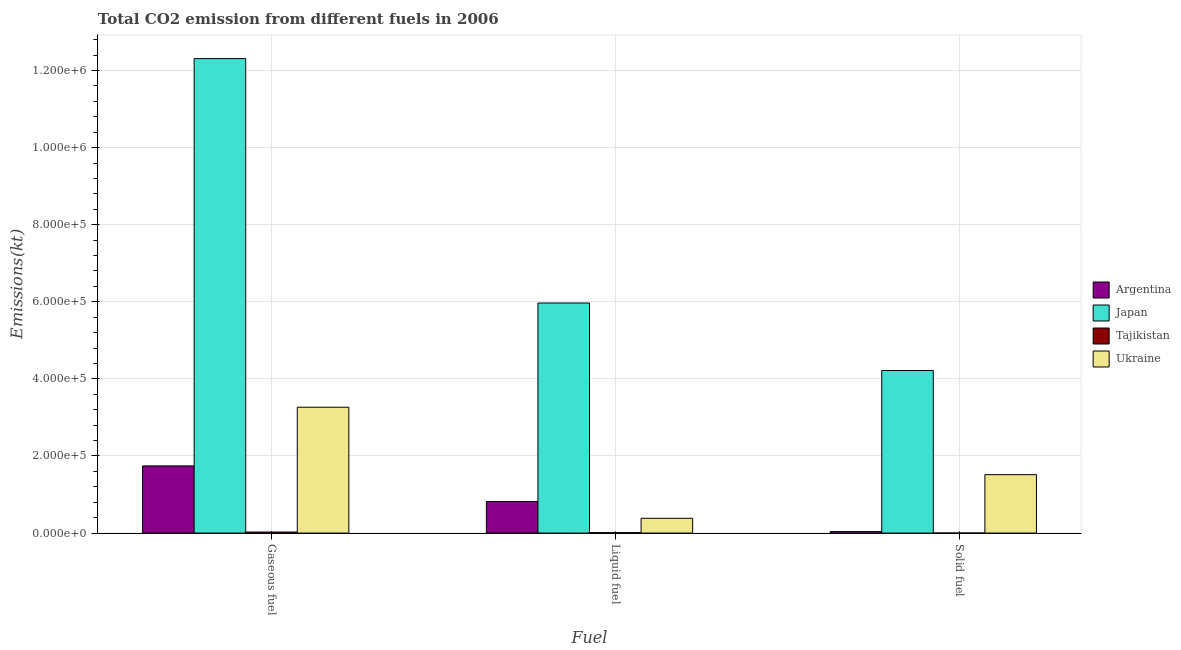How many different coloured bars are there?
Keep it short and to the point. 4. Are the number of bars per tick equal to the number of legend labels?
Ensure brevity in your answer.  Yes. Are the number of bars on each tick of the X-axis equal?
Your answer should be very brief. Yes. How many bars are there on the 1st tick from the left?
Your answer should be compact. 4. What is the label of the 3rd group of bars from the left?
Your answer should be compact. Solid fuel. What is the amount of co2 emissions from liquid fuel in Ukraine?
Your response must be concise. 3.84e+04. Across all countries, what is the maximum amount of co2 emissions from gaseous fuel?
Ensure brevity in your answer.  1.23e+06. Across all countries, what is the minimum amount of co2 emissions from solid fuel?
Your answer should be very brief. 176.02. In which country was the amount of co2 emissions from solid fuel maximum?
Give a very brief answer. Japan. In which country was the amount of co2 emissions from gaseous fuel minimum?
Ensure brevity in your answer.  Tajikistan. What is the total amount of co2 emissions from liquid fuel in the graph?
Provide a short and direct response. 7.18e+05. What is the difference between the amount of co2 emissions from liquid fuel in Japan and that in Ukraine?
Make the answer very short. 5.58e+05. What is the difference between the amount of co2 emissions from liquid fuel in Ukraine and the amount of co2 emissions from gaseous fuel in Argentina?
Your response must be concise. -1.36e+05. What is the average amount of co2 emissions from solid fuel per country?
Provide a succinct answer. 1.44e+05. What is the difference between the amount of co2 emissions from liquid fuel and amount of co2 emissions from solid fuel in Tajikistan?
Make the answer very short. 935.09. What is the ratio of the amount of co2 emissions from liquid fuel in Ukraine to that in Argentina?
Provide a succinct answer. 0.47. What is the difference between the highest and the second highest amount of co2 emissions from gaseous fuel?
Keep it short and to the point. 9.04e+05. What is the difference between the highest and the lowest amount of co2 emissions from solid fuel?
Make the answer very short. 4.22e+05. Is the sum of the amount of co2 emissions from gaseous fuel in Japan and Ukraine greater than the maximum amount of co2 emissions from liquid fuel across all countries?
Your answer should be compact. Yes. What does the 3rd bar from the left in Liquid fuel represents?
Ensure brevity in your answer.  Tajikistan. What does the 1st bar from the right in Gaseous fuel represents?
Your answer should be compact. Ukraine. Is it the case that in every country, the sum of the amount of co2 emissions from gaseous fuel and amount of co2 emissions from liquid fuel is greater than the amount of co2 emissions from solid fuel?
Your answer should be compact. Yes. Are all the bars in the graph horizontal?
Make the answer very short. No. How many countries are there in the graph?
Keep it short and to the point. 4. What is the title of the graph?
Offer a terse response. Total CO2 emission from different fuels in 2006. Does "Guinea" appear as one of the legend labels in the graph?
Make the answer very short. No. What is the label or title of the X-axis?
Provide a short and direct response. Fuel. What is the label or title of the Y-axis?
Ensure brevity in your answer.  Emissions(kt). What is the Emissions(kt) in Argentina in Gaseous fuel?
Offer a terse response. 1.74e+05. What is the Emissions(kt) in Japan in Gaseous fuel?
Keep it short and to the point. 1.23e+06. What is the Emissions(kt) in Tajikistan in Gaseous fuel?
Your response must be concise. 2658.57. What is the Emissions(kt) in Ukraine in Gaseous fuel?
Offer a very short reply. 3.26e+05. What is the Emissions(kt) in Argentina in Liquid fuel?
Offer a terse response. 8.20e+04. What is the Emissions(kt) in Japan in Liquid fuel?
Your answer should be compact. 5.97e+05. What is the Emissions(kt) of Tajikistan in Liquid fuel?
Keep it short and to the point. 1111.1. What is the Emissions(kt) of Ukraine in Liquid fuel?
Your answer should be compact. 3.84e+04. What is the Emissions(kt) of Argentina in Solid fuel?
Your answer should be compact. 3868.68. What is the Emissions(kt) in Japan in Solid fuel?
Offer a terse response. 4.22e+05. What is the Emissions(kt) of Tajikistan in Solid fuel?
Give a very brief answer. 176.02. What is the Emissions(kt) in Ukraine in Solid fuel?
Ensure brevity in your answer.  1.52e+05. Across all Fuel, what is the maximum Emissions(kt) of Argentina?
Give a very brief answer. 1.74e+05. Across all Fuel, what is the maximum Emissions(kt) of Japan?
Keep it short and to the point. 1.23e+06. Across all Fuel, what is the maximum Emissions(kt) in Tajikistan?
Give a very brief answer. 2658.57. Across all Fuel, what is the maximum Emissions(kt) of Ukraine?
Your answer should be very brief. 3.26e+05. Across all Fuel, what is the minimum Emissions(kt) in Argentina?
Your response must be concise. 3868.68. Across all Fuel, what is the minimum Emissions(kt) in Japan?
Offer a terse response. 4.22e+05. Across all Fuel, what is the minimum Emissions(kt) in Tajikistan?
Give a very brief answer. 176.02. Across all Fuel, what is the minimum Emissions(kt) in Ukraine?
Your answer should be compact. 3.84e+04. What is the total Emissions(kt) of Argentina in the graph?
Ensure brevity in your answer.  2.60e+05. What is the total Emissions(kt) in Japan in the graph?
Provide a succinct answer. 2.25e+06. What is the total Emissions(kt) of Tajikistan in the graph?
Provide a succinct answer. 3945.69. What is the total Emissions(kt) in Ukraine in the graph?
Keep it short and to the point. 5.16e+05. What is the difference between the Emissions(kt) of Argentina in Gaseous fuel and that in Liquid fuel?
Your response must be concise. 9.23e+04. What is the difference between the Emissions(kt) of Japan in Gaseous fuel and that in Liquid fuel?
Make the answer very short. 6.34e+05. What is the difference between the Emissions(kt) of Tajikistan in Gaseous fuel and that in Liquid fuel?
Your response must be concise. 1547.47. What is the difference between the Emissions(kt) in Ukraine in Gaseous fuel and that in Liquid fuel?
Offer a terse response. 2.88e+05. What is the difference between the Emissions(kt) in Argentina in Gaseous fuel and that in Solid fuel?
Make the answer very short. 1.70e+05. What is the difference between the Emissions(kt) of Japan in Gaseous fuel and that in Solid fuel?
Your answer should be very brief. 8.09e+05. What is the difference between the Emissions(kt) in Tajikistan in Gaseous fuel and that in Solid fuel?
Give a very brief answer. 2482.56. What is the difference between the Emissions(kt) in Ukraine in Gaseous fuel and that in Solid fuel?
Make the answer very short. 1.75e+05. What is the difference between the Emissions(kt) in Argentina in Liquid fuel and that in Solid fuel?
Offer a terse response. 7.81e+04. What is the difference between the Emissions(kt) in Japan in Liquid fuel and that in Solid fuel?
Your response must be concise. 1.75e+05. What is the difference between the Emissions(kt) of Tajikistan in Liquid fuel and that in Solid fuel?
Keep it short and to the point. 935.09. What is the difference between the Emissions(kt) in Ukraine in Liquid fuel and that in Solid fuel?
Ensure brevity in your answer.  -1.13e+05. What is the difference between the Emissions(kt) of Argentina in Gaseous fuel and the Emissions(kt) of Japan in Liquid fuel?
Make the answer very short. -4.23e+05. What is the difference between the Emissions(kt) in Argentina in Gaseous fuel and the Emissions(kt) in Tajikistan in Liquid fuel?
Provide a short and direct response. 1.73e+05. What is the difference between the Emissions(kt) of Argentina in Gaseous fuel and the Emissions(kt) of Ukraine in Liquid fuel?
Ensure brevity in your answer.  1.36e+05. What is the difference between the Emissions(kt) in Japan in Gaseous fuel and the Emissions(kt) in Tajikistan in Liquid fuel?
Provide a succinct answer. 1.23e+06. What is the difference between the Emissions(kt) of Japan in Gaseous fuel and the Emissions(kt) of Ukraine in Liquid fuel?
Ensure brevity in your answer.  1.19e+06. What is the difference between the Emissions(kt) of Tajikistan in Gaseous fuel and the Emissions(kt) of Ukraine in Liquid fuel?
Your response must be concise. -3.57e+04. What is the difference between the Emissions(kt) of Argentina in Gaseous fuel and the Emissions(kt) of Japan in Solid fuel?
Provide a succinct answer. -2.47e+05. What is the difference between the Emissions(kt) of Argentina in Gaseous fuel and the Emissions(kt) of Tajikistan in Solid fuel?
Give a very brief answer. 1.74e+05. What is the difference between the Emissions(kt) of Argentina in Gaseous fuel and the Emissions(kt) of Ukraine in Solid fuel?
Your response must be concise. 2.27e+04. What is the difference between the Emissions(kt) in Japan in Gaseous fuel and the Emissions(kt) in Tajikistan in Solid fuel?
Your answer should be very brief. 1.23e+06. What is the difference between the Emissions(kt) of Japan in Gaseous fuel and the Emissions(kt) of Ukraine in Solid fuel?
Your answer should be compact. 1.08e+06. What is the difference between the Emissions(kt) of Tajikistan in Gaseous fuel and the Emissions(kt) of Ukraine in Solid fuel?
Provide a succinct answer. -1.49e+05. What is the difference between the Emissions(kt) in Argentina in Liquid fuel and the Emissions(kt) in Japan in Solid fuel?
Provide a succinct answer. -3.40e+05. What is the difference between the Emissions(kt) in Argentina in Liquid fuel and the Emissions(kt) in Tajikistan in Solid fuel?
Ensure brevity in your answer.  8.18e+04. What is the difference between the Emissions(kt) of Argentina in Liquid fuel and the Emissions(kt) of Ukraine in Solid fuel?
Your answer should be compact. -6.95e+04. What is the difference between the Emissions(kt) of Japan in Liquid fuel and the Emissions(kt) of Tajikistan in Solid fuel?
Give a very brief answer. 5.97e+05. What is the difference between the Emissions(kt) of Japan in Liquid fuel and the Emissions(kt) of Ukraine in Solid fuel?
Your answer should be compact. 4.45e+05. What is the difference between the Emissions(kt) of Tajikistan in Liquid fuel and the Emissions(kt) of Ukraine in Solid fuel?
Make the answer very short. -1.50e+05. What is the average Emissions(kt) of Argentina per Fuel?
Offer a very short reply. 8.67e+04. What is the average Emissions(kt) of Japan per Fuel?
Make the answer very short. 7.50e+05. What is the average Emissions(kt) in Tajikistan per Fuel?
Your answer should be very brief. 1315.23. What is the average Emissions(kt) in Ukraine per Fuel?
Provide a short and direct response. 1.72e+05. What is the difference between the Emissions(kt) in Argentina and Emissions(kt) in Japan in Gaseous fuel?
Ensure brevity in your answer.  -1.06e+06. What is the difference between the Emissions(kt) in Argentina and Emissions(kt) in Tajikistan in Gaseous fuel?
Your answer should be compact. 1.72e+05. What is the difference between the Emissions(kt) in Argentina and Emissions(kt) in Ukraine in Gaseous fuel?
Ensure brevity in your answer.  -1.52e+05. What is the difference between the Emissions(kt) of Japan and Emissions(kt) of Tajikistan in Gaseous fuel?
Provide a short and direct response. 1.23e+06. What is the difference between the Emissions(kt) in Japan and Emissions(kt) in Ukraine in Gaseous fuel?
Your response must be concise. 9.04e+05. What is the difference between the Emissions(kt) in Tajikistan and Emissions(kt) in Ukraine in Gaseous fuel?
Your response must be concise. -3.24e+05. What is the difference between the Emissions(kt) in Argentina and Emissions(kt) in Japan in Liquid fuel?
Give a very brief answer. -5.15e+05. What is the difference between the Emissions(kt) in Argentina and Emissions(kt) in Tajikistan in Liquid fuel?
Offer a very short reply. 8.09e+04. What is the difference between the Emissions(kt) in Argentina and Emissions(kt) in Ukraine in Liquid fuel?
Offer a very short reply. 4.36e+04. What is the difference between the Emissions(kt) in Japan and Emissions(kt) in Tajikistan in Liquid fuel?
Your answer should be very brief. 5.96e+05. What is the difference between the Emissions(kt) of Japan and Emissions(kt) of Ukraine in Liquid fuel?
Make the answer very short. 5.58e+05. What is the difference between the Emissions(kt) in Tajikistan and Emissions(kt) in Ukraine in Liquid fuel?
Provide a succinct answer. -3.72e+04. What is the difference between the Emissions(kt) in Argentina and Emissions(kt) in Japan in Solid fuel?
Make the answer very short. -4.18e+05. What is the difference between the Emissions(kt) in Argentina and Emissions(kt) in Tajikistan in Solid fuel?
Offer a very short reply. 3692.67. What is the difference between the Emissions(kt) of Argentina and Emissions(kt) of Ukraine in Solid fuel?
Ensure brevity in your answer.  -1.48e+05. What is the difference between the Emissions(kt) in Japan and Emissions(kt) in Tajikistan in Solid fuel?
Make the answer very short. 4.22e+05. What is the difference between the Emissions(kt) in Japan and Emissions(kt) in Ukraine in Solid fuel?
Your answer should be compact. 2.70e+05. What is the difference between the Emissions(kt) of Tajikistan and Emissions(kt) of Ukraine in Solid fuel?
Ensure brevity in your answer.  -1.51e+05. What is the ratio of the Emissions(kt) of Argentina in Gaseous fuel to that in Liquid fuel?
Ensure brevity in your answer.  2.13. What is the ratio of the Emissions(kt) in Japan in Gaseous fuel to that in Liquid fuel?
Offer a very short reply. 2.06. What is the ratio of the Emissions(kt) in Tajikistan in Gaseous fuel to that in Liquid fuel?
Offer a very short reply. 2.39. What is the ratio of the Emissions(kt) in Ukraine in Gaseous fuel to that in Liquid fuel?
Offer a terse response. 8.51. What is the ratio of the Emissions(kt) of Argentina in Gaseous fuel to that in Solid fuel?
Give a very brief answer. 45.04. What is the ratio of the Emissions(kt) of Japan in Gaseous fuel to that in Solid fuel?
Offer a terse response. 2.92. What is the ratio of the Emissions(kt) of Tajikistan in Gaseous fuel to that in Solid fuel?
Keep it short and to the point. 15.1. What is the ratio of the Emissions(kt) of Ukraine in Gaseous fuel to that in Solid fuel?
Give a very brief answer. 2.15. What is the ratio of the Emissions(kt) of Argentina in Liquid fuel to that in Solid fuel?
Provide a succinct answer. 21.19. What is the ratio of the Emissions(kt) in Japan in Liquid fuel to that in Solid fuel?
Offer a terse response. 1.42. What is the ratio of the Emissions(kt) in Tajikistan in Liquid fuel to that in Solid fuel?
Offer a very short reply. 6.31. What is the ratio of the Emissions(kt) of Ukraine in Liquid fuel to that in Solid fuel?
Offer a very short reply. 0.25. What is the difference between the highest and the second highest Emissions(kt) in Argentina?
Your answer should be compact. 9.23e+04. What is the difference between the highest and the second highest Emissions(kt) in Japan?
Your answer should be compact. 6.34e+05. What is the difference between the highest and the second highest Emissions(kt) in Tajikistan?
Keep it short and to the point. 1547.47. What is the difference between the highest and the second highest Emissions(kt) in Ukraine?
Your answer should be compact. 1.75e+05. What is the difference between the highest and the lowest Emissions(kt) in Argentina?
Your answer should be very brief. 1.70e+05. What is the difference between the highest and the lowest Emissions(kt) of Japan?
Your answer should be very brief. 8.09e+05. What is the difference between the highest and the lowest Emissions(kt) of Tajikistan?
Your answer should be very brief. 2482.56. What is the difference between the highest and the lowest Emissions(kt) in Ukraine?
Offer a terse response. 2.88e+05. 